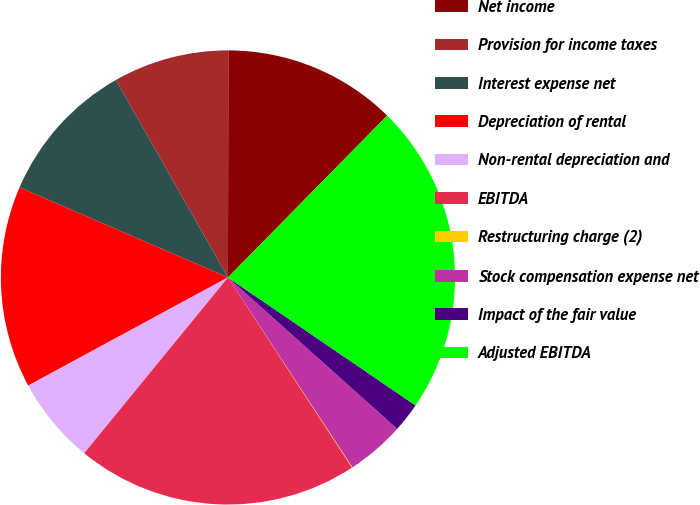<chart> <loc_0><loc_0><loc_500><loc_500><pie_chart><fcel>Net income<fcel>Provision for income taxes<fcel>Interest expense net<fcel>Depreciation of rental<fcel>Non-rental depreciation and<fcel>EBITDA<fcel>Restructuring charge (2)<fcel>Stock compensation expense net<fcel>Impact of the fair value<fcel>Adjusted EBITDA<nl><fcel>12.34%<fcel>8.24%<fcel>10.29%<fcel>14.39%<fcel>6.19%<fcel>20.11%<fcel>0.04%<fcel>4.14%<fcel>2.09%<fcel>22.16%<nl></chart> 